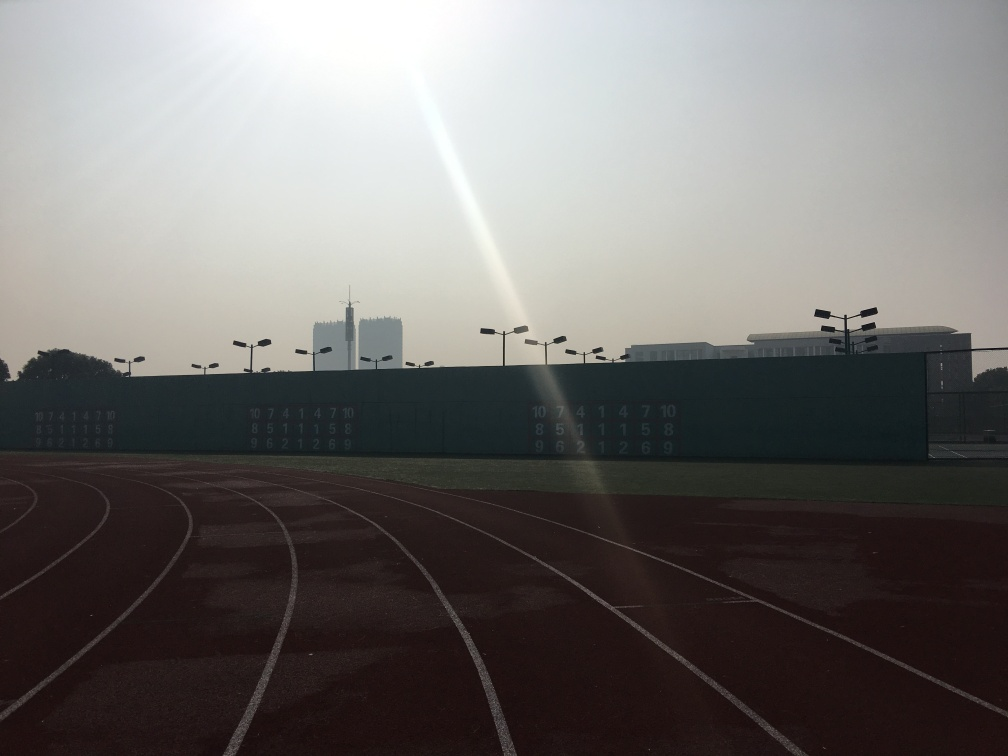How does the lighting condition affect the mood and visual impact of the photograph? The lighting condition, with the sun casting a backlight and creating a lens flare, provides a somewhat ethereal and serene mood to the image. It can give the impression of a tranquil early morning setting, inviting reflection. The dramatic contrast between light and shadow adds depth, although it could also affect the clarity of certain elements within the photo. Overall, the lighting can evoke a sense of calm and stillness, potentially heightening the visual impact. 